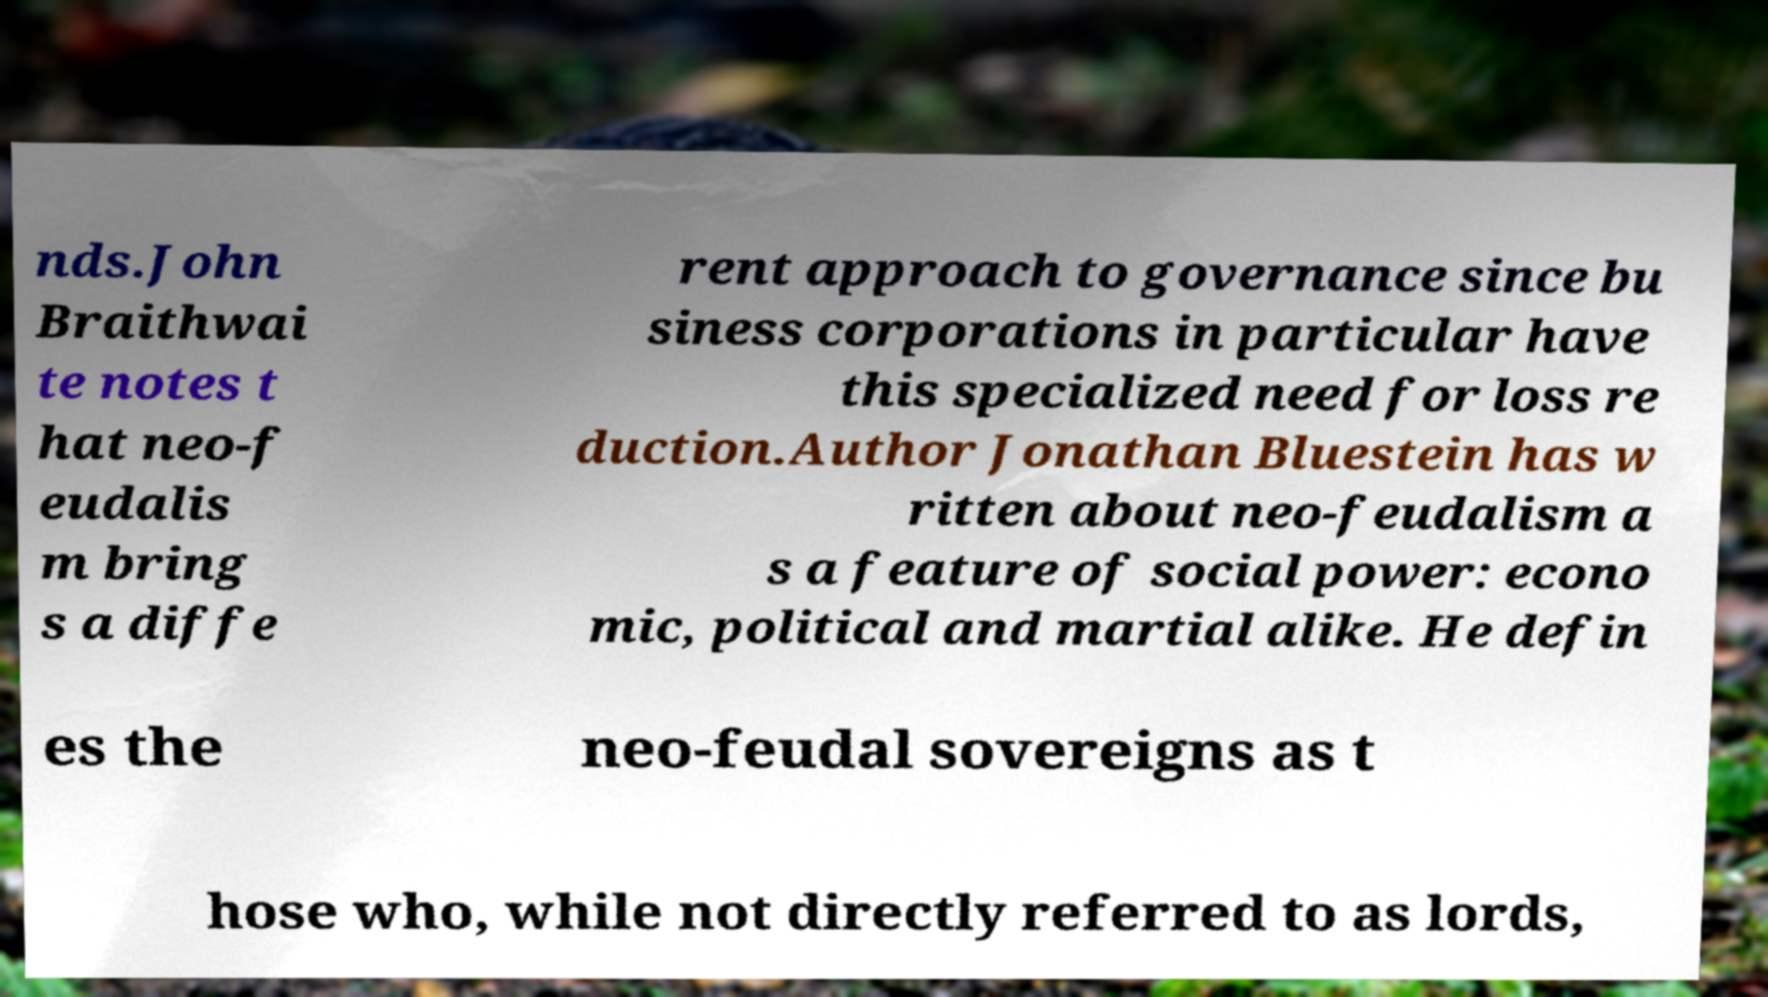Could you extract and type out the text from this image? nds.John Braithwai te notes t hat neo-f eudalis m bring s a diffe rent approach to governance since bu siness corporations in particular have this specialized need for loss re duction.Author Jonathan Bluestein has w ritten about neo-feudalism a s a feature of social power: econo mic, political and martial alike. He defin es the neo-feudal sovereigns as t hose who, while not directly referred to as lords, 